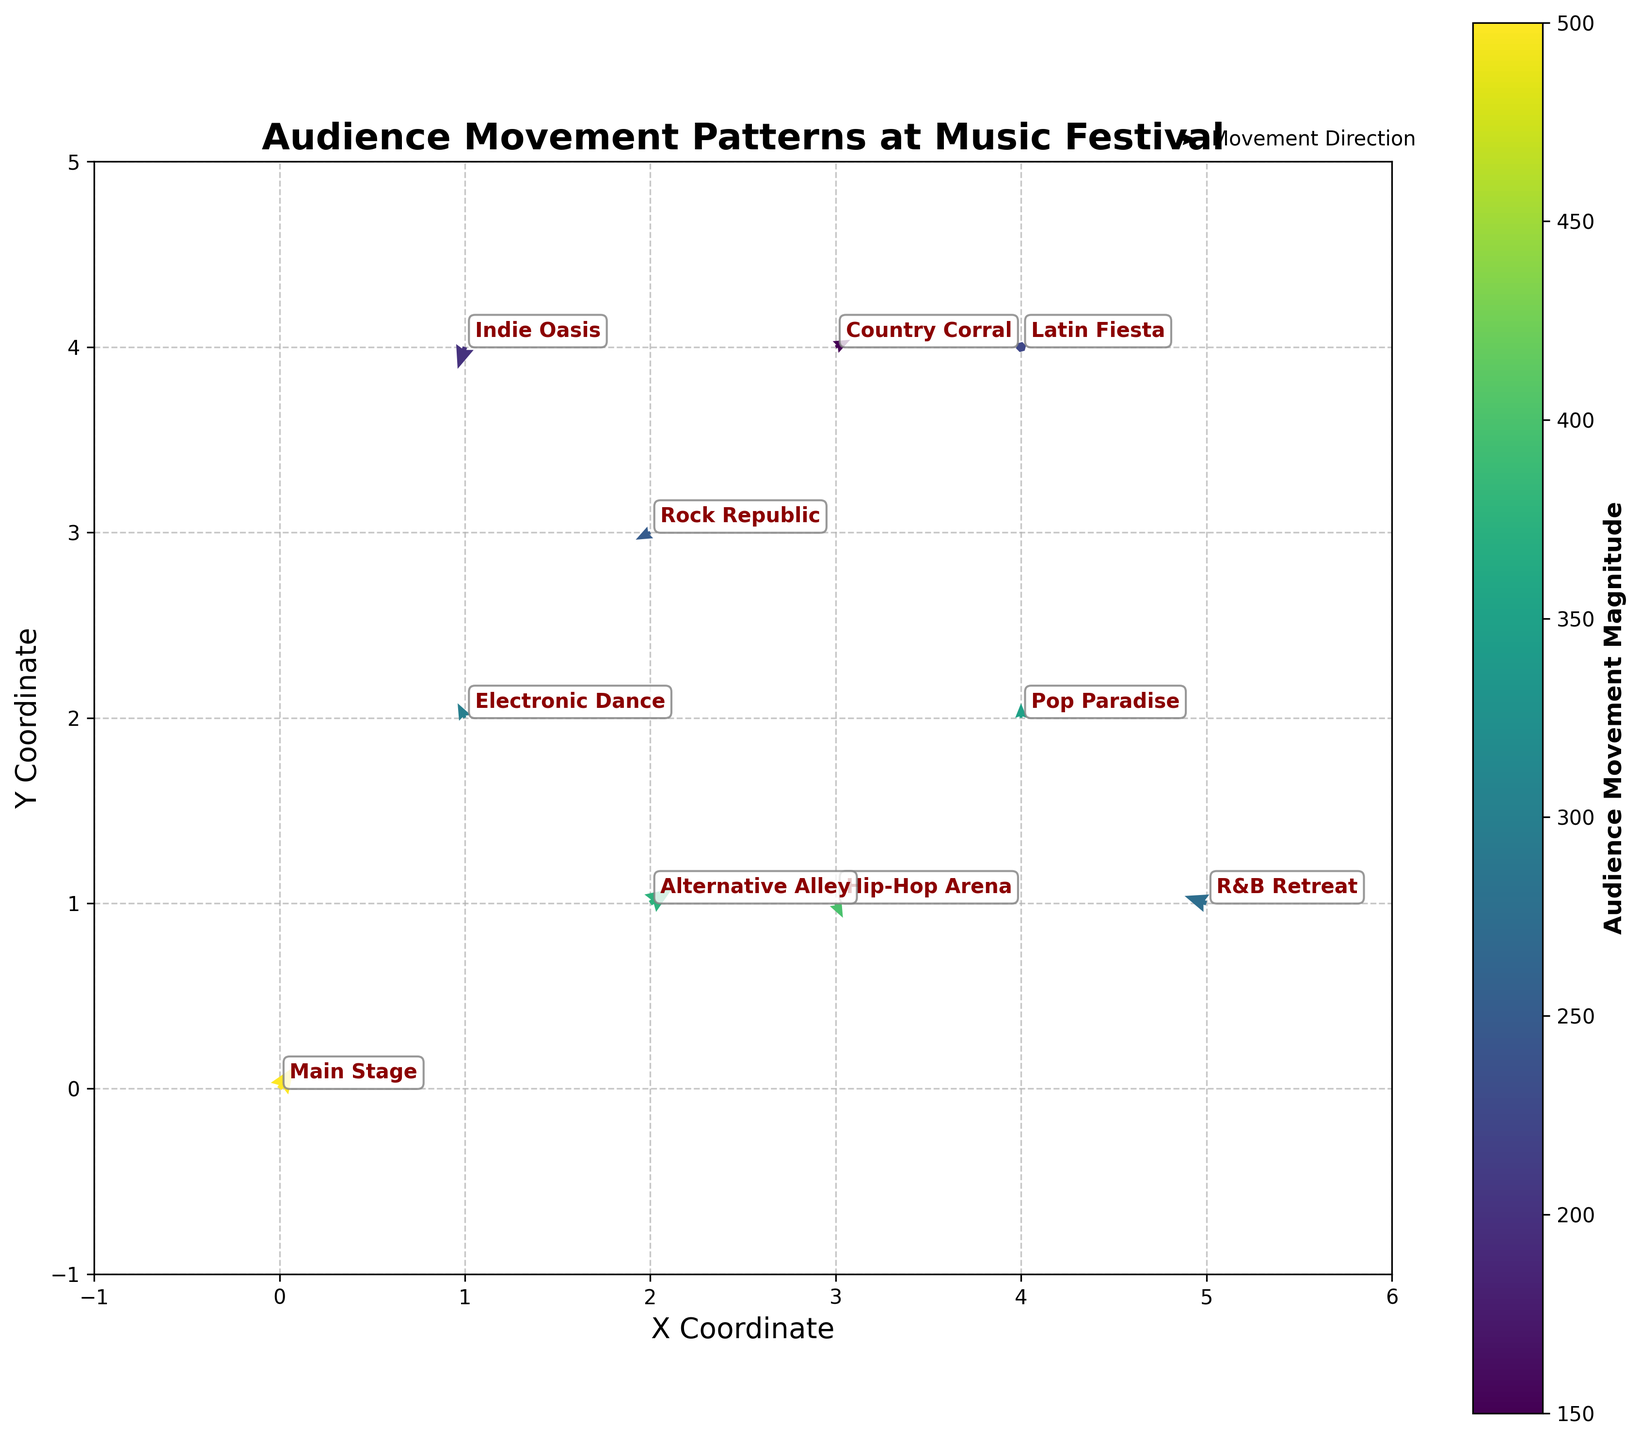What is the title of the plot? The title of the plot is located at the top center of the figure and is displayed in a larger, bold font. It describes the main theme or subject of the plot.
Answer: Audience Movement Patterns at Music Festival How many stages are represented in the plot? Count the number of unique stage names annotated on the plot. Each stage name appears once.
Answer: 10 Which stage has the highest audience movement magnitude? Look at the color intensity of the arrows or refer to the color bar for the highest value. Then, identify the corresponding stage name from the annotations.
Answer: Main Stage Which stage has the most substantial movement towards the negative x-axis? Identify the arrows pointing to the left in the plot. Then, find out which of these arrows has the largest magnitude and note the corresponding stage.
Answer: Rock Republic What is the average x-coordinate of all stages? Sum the x-coordinates of all stages and divide by the number of stages. The coordinates are 0, 1, 3, 2, 4, 1, 3, 5, 4, 2. The sum is (= 0+1+3+2+4+1+3+5+4+2 = 25); then divide by 10.
Answer: 2.5 Which two stages have the exact same y-coordinates? Look for stages with the same y-coordinate values. Verify by checking each pair.
Answer: Electronic Dance and Alternative Alley How does the audience movement from Main Stage compare to the movement from Pop Paradise? compare the direction and magnitude of the arrows for Main Stage and Pop Paradise. Identify the visual differences in both magnitude and direction.
Answer: Main Stage has a higher magnitude and moves up-right, while Pop Paradise moves straight up with lower magnitude Which stage exhibits the most downward movement? Identify the arrow with the most negative y-component. Look for the arrow with the largest downward vector.
Answer: Indie Oasis What is the total movement magnitude for all stages combined? Sum the magnitudes from all the stages. The magnitudes are 500, 300, 400, 250, 350, 200, 150, 275, 225, 375. The sum is (= 3025).
Answer: 3025 From which stage does the audience move most towards the positive y-axis? Look for the arrows pointing most strongly upwards. Then compare their magnitudes to identify the largest one.
Answer: Pop Paradise 